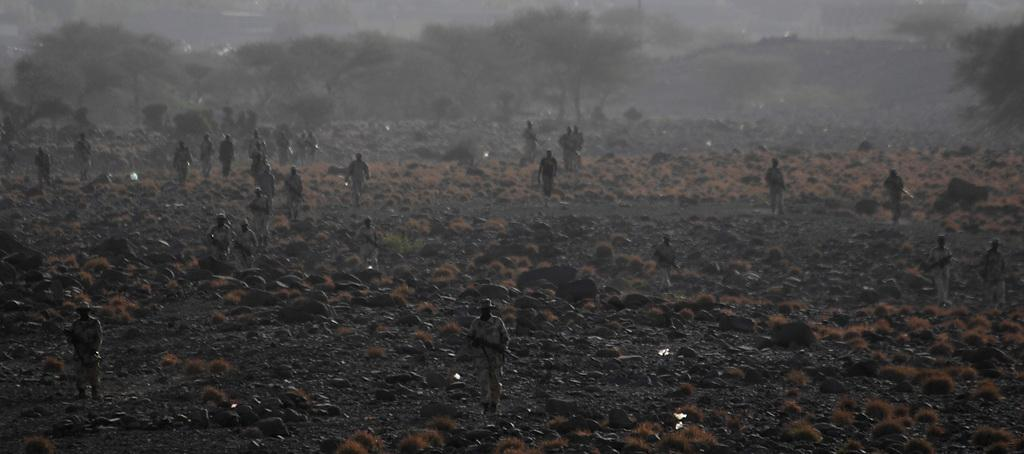How many people are in the image? There is a group of people in the image, but the exact number cannot be determined from the provided facts. What can be seen on the ground in the image? There are stones and plants on the ground in the image. What is visible in the background of the image? There are trees and the sky visible in the background of the image. What type of liquid is being sprayed from the hose in the image? There is no hose present in the image, so it is not possible to answer that question. 